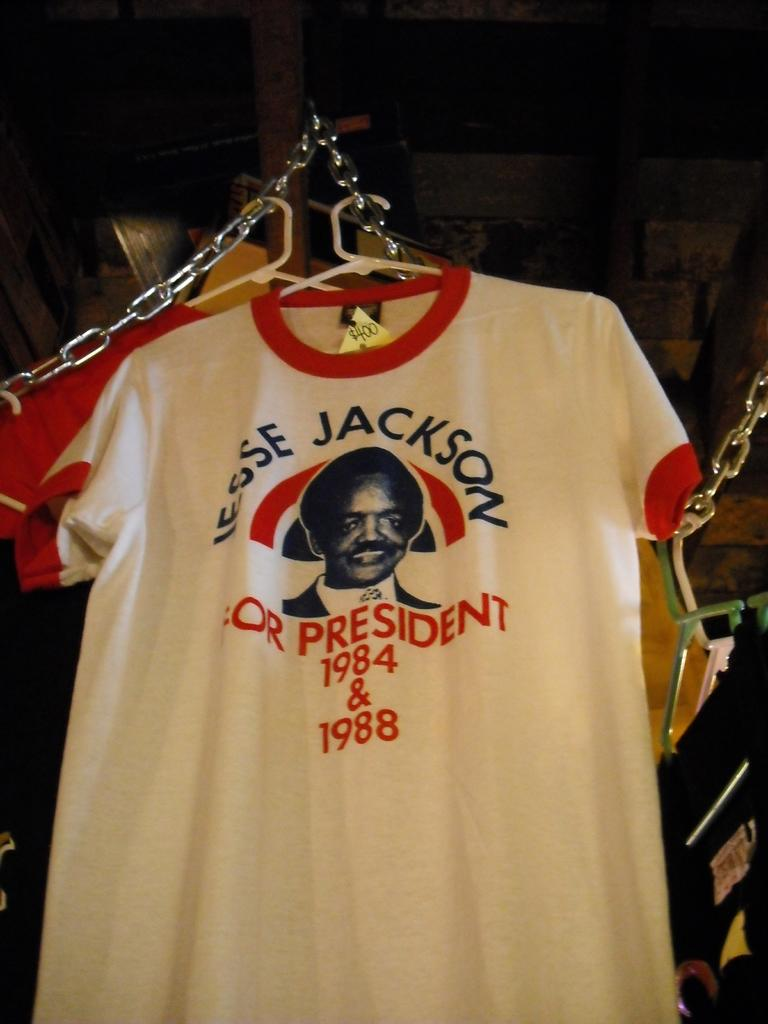<image>
Summarize the visual content of the image. An old Jessie Jackson presidental campaign t-shirt hanging on a hanger. 